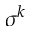<formula> <loc_0><loc_0><loc_500><loc_500>\sigma ^ { k }</formula> 